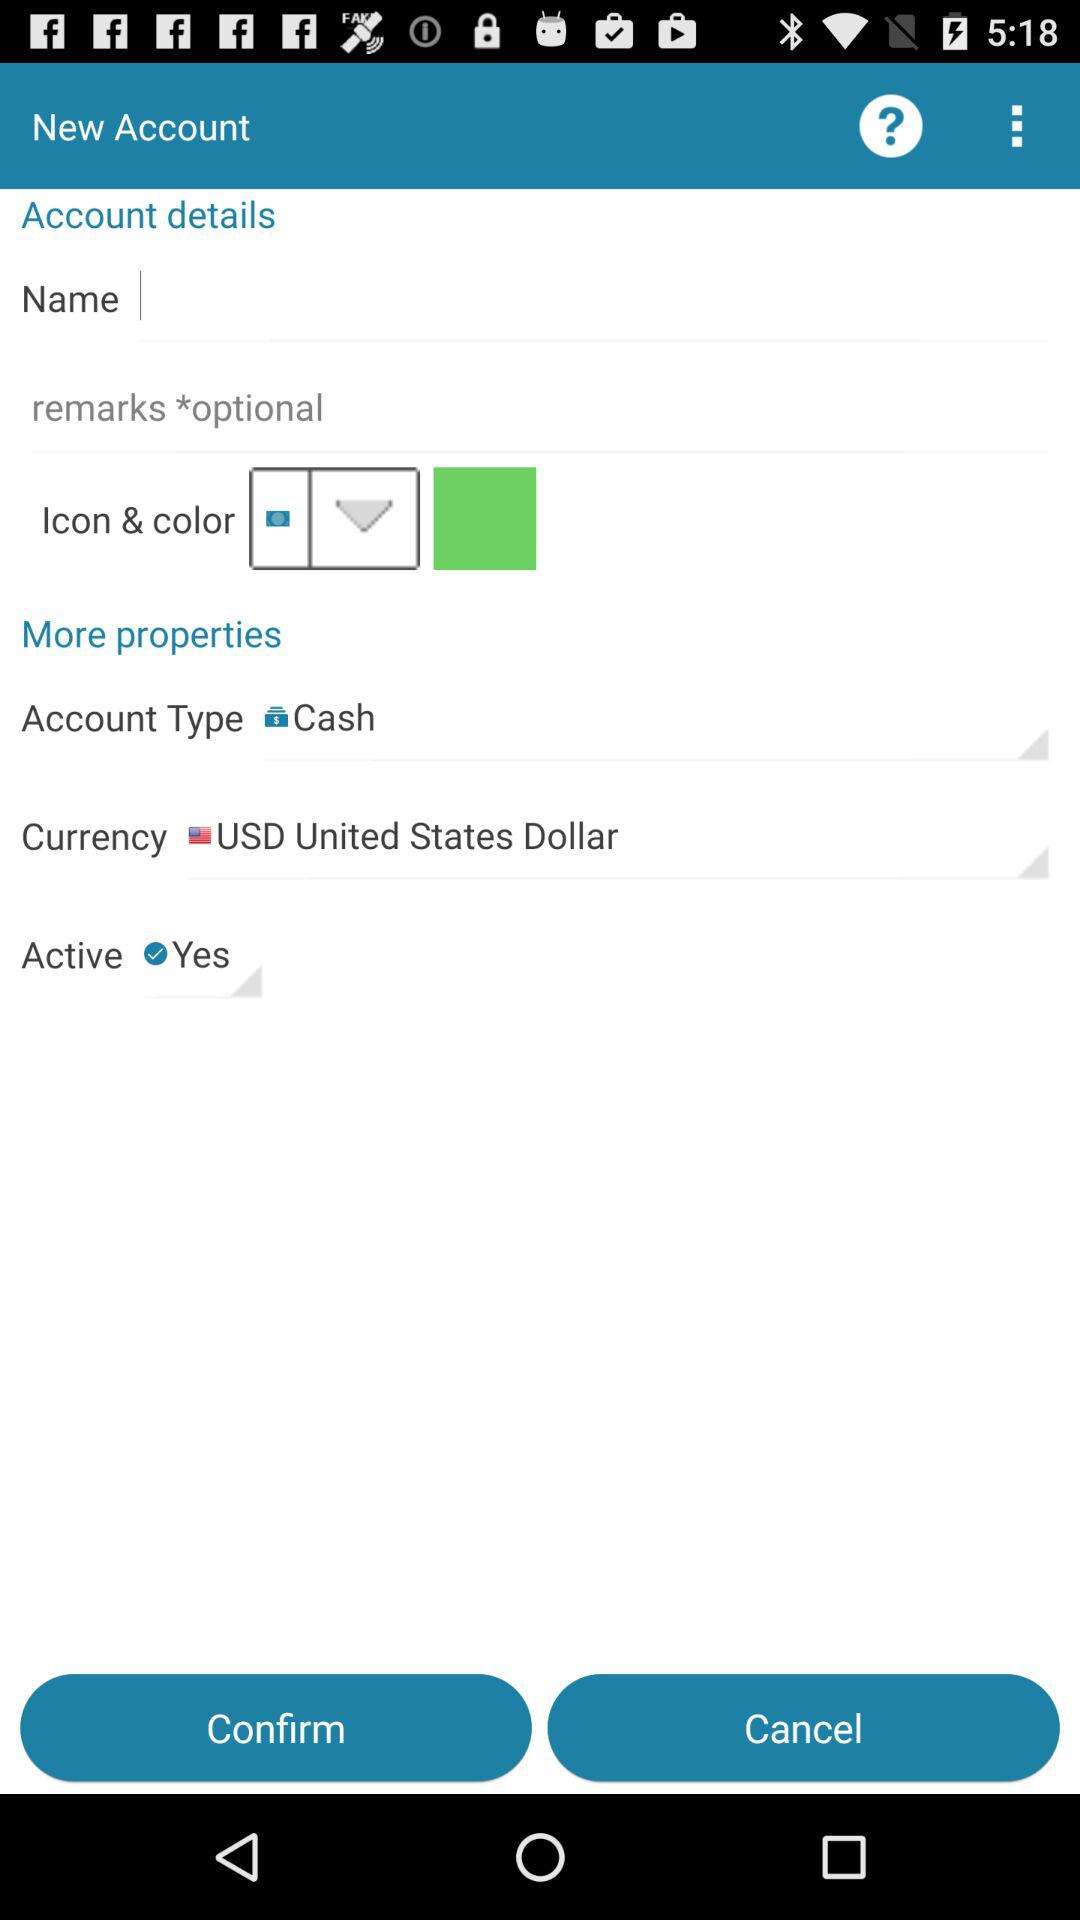What is selected in "Active"? The option "Yes" is selected in "Active". 